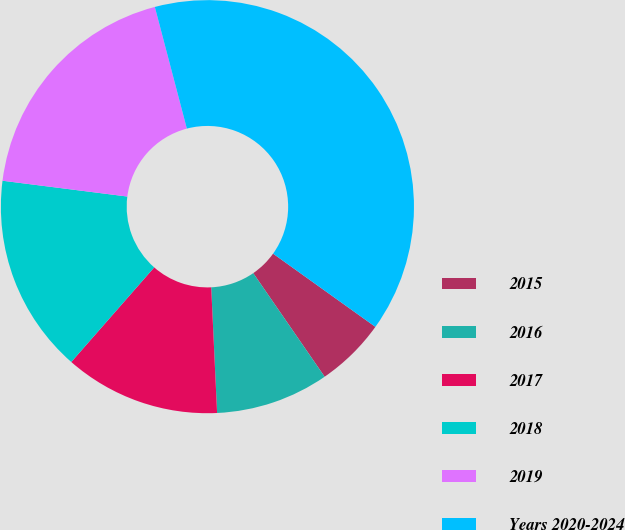Convert chart to OTSL. <chart><loc_0><loc_0><loc_500><loc_500><pie_chart><fcel>2015<fcel>2016<fcel>2017<fcel>2018<fcel>2019<fcel>Years 2020-2024<nl><fcel>5.51%<fcel>8.86%<fcel>12.2%<fcel>15.55%<fcel>18.9%<fcel>38.98%<nl></chart> 